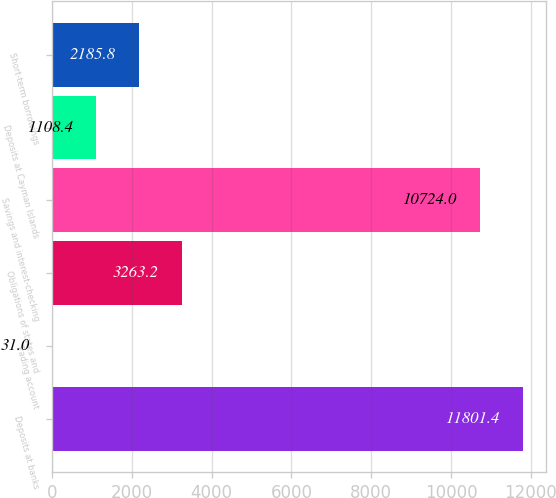<chart> <loc_0><loc_0><loc_500><loc_500><bar_chart><fcel>Deposits at banks<fcel>Trading account<fcel>Obligations of states and<fcel>Savings and interest-checking<fcel>Deposits at Cayman Islands<fcel>Short-term borrowings<nl><fcel>11801.4<fcel>31<fcel>3263.2<fcel>10724<fcel>1108.4<fcel>2185.8<nl></chart> 